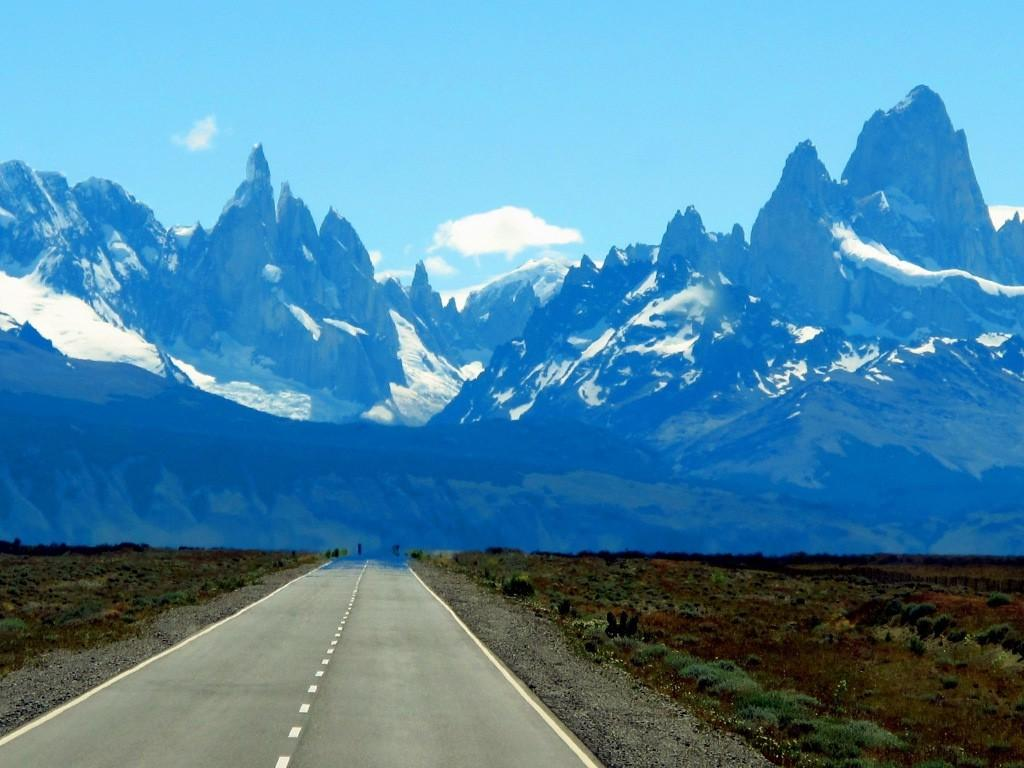What type of natural formation can be seen in the image? There are snow mountains in the image. What is located at the bottom of the image? There is a road at the bottom of the image. What type of vegetation is present beside the road? There is grass and plants beside the road. What is visible at the top of the image? The sky is visible at the top of the image. What can be seen in the sky? Clouds are present in the sky. Can you tell me how many zebras are walking in harmony on the road in the image? There are no zebras present in the image, and therefore no such activity can be observed. What is the process of copying the clouds in the sky in the image? There is no process of copying the clouds in the sky in the image, as they are a natural part of the scene. 